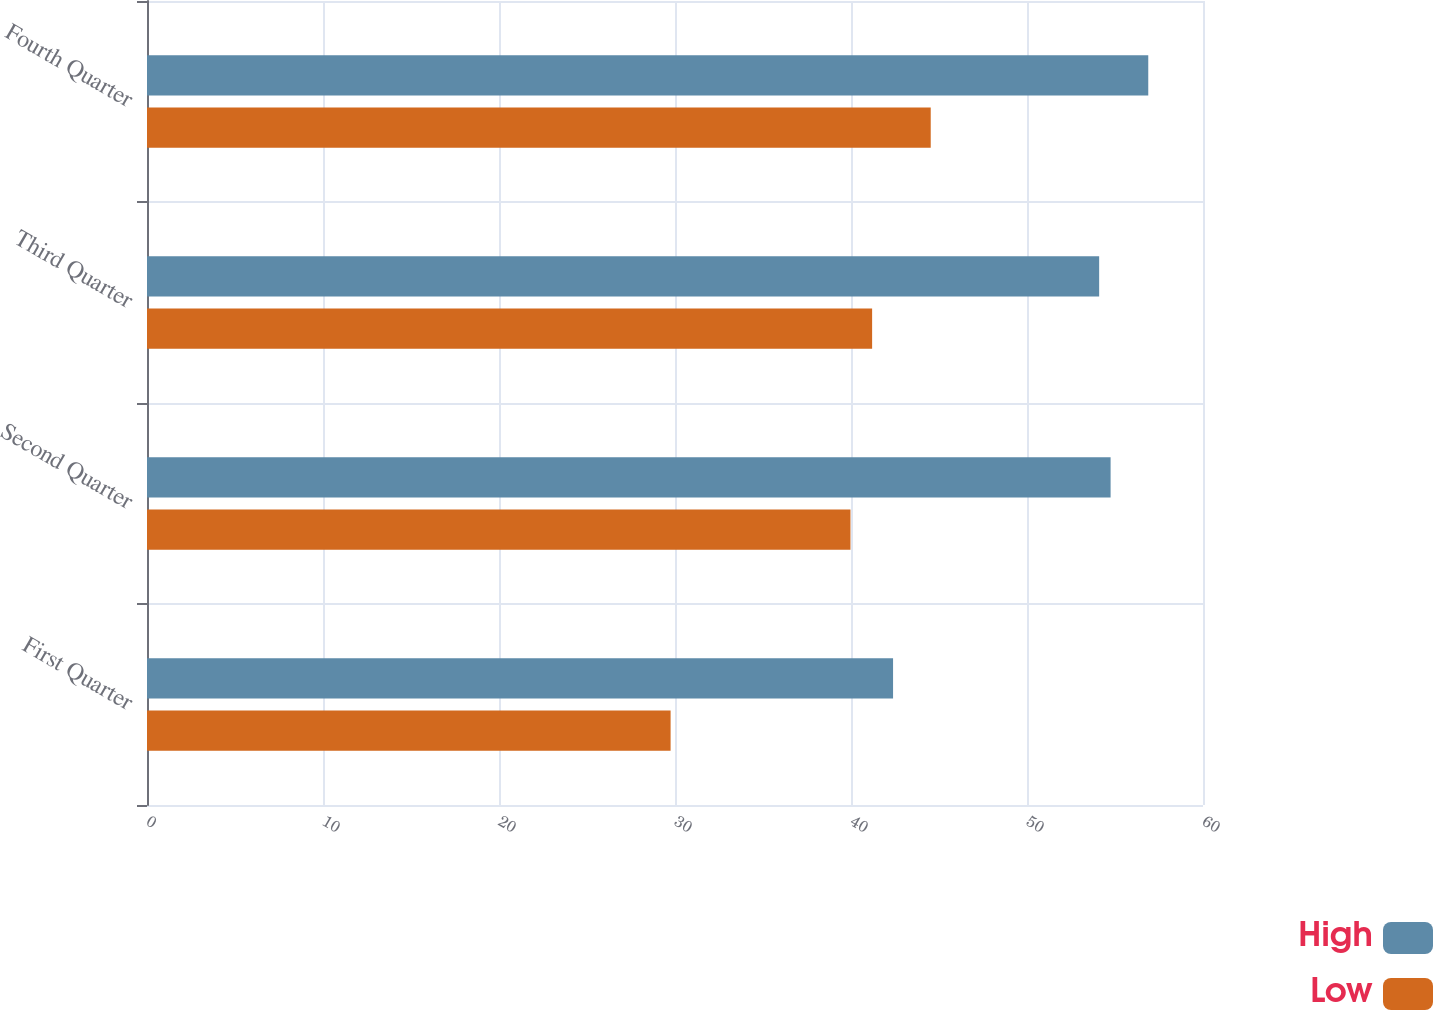<chart> <loc_0><loc_0><loc_500><loc_500><stacked_bar_chart><ecel><fcel>First Quarter<fcel>Second Quarter<fcel>Third Quarter<fcel>Fourth Quarter<nl><fcel>High<fcel>42.39<fcel>54.75<fcel>54.1<fcel>56.89<nl><fcel>Low<fcel>29.75<fcel>39.97<fcel>41.2<fcel>44.53<nl></chart> 